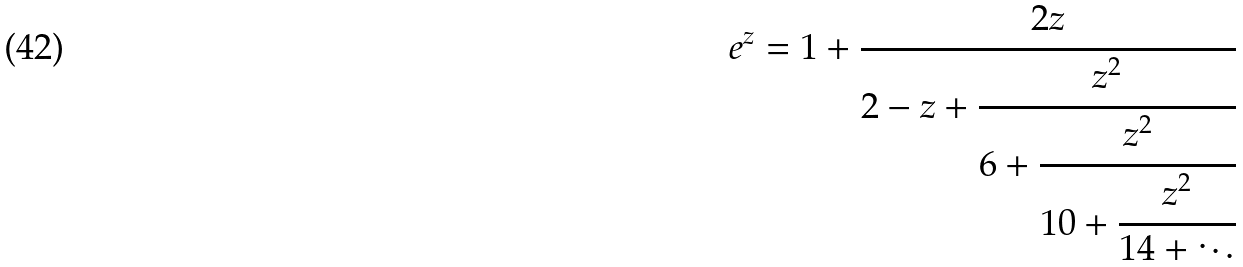Convert formula to latex. <formula><loc_0><loc_0><loc_500><loc_500>e ^ { z } = 1 + { \cfrac { 2 z } { 2 - z + { \cfrac { z ^ { 2 } } { 6 + { \cfrac { z ^ { 2 } } { 1 0 + { \cfrac { z ^ { 2 } } { 1 4 + \ddots } } } } } } } }</formula> 